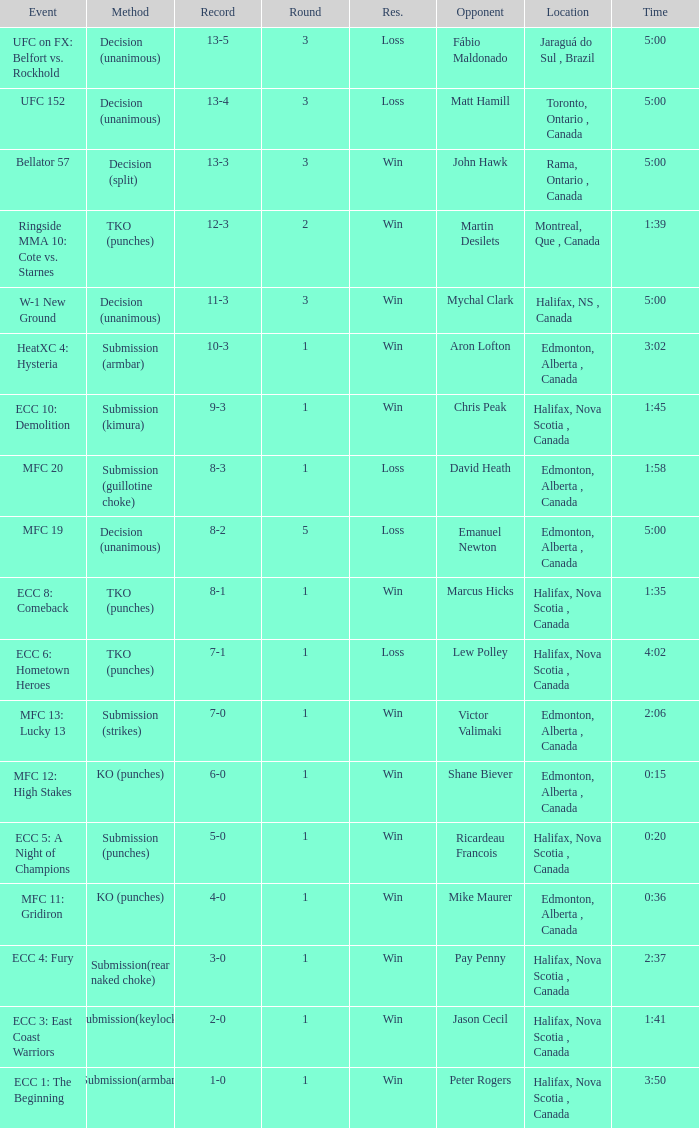What is the location of the match with an event of ecc 8: comeback? Halifax, Nova Scotia , Canada. 